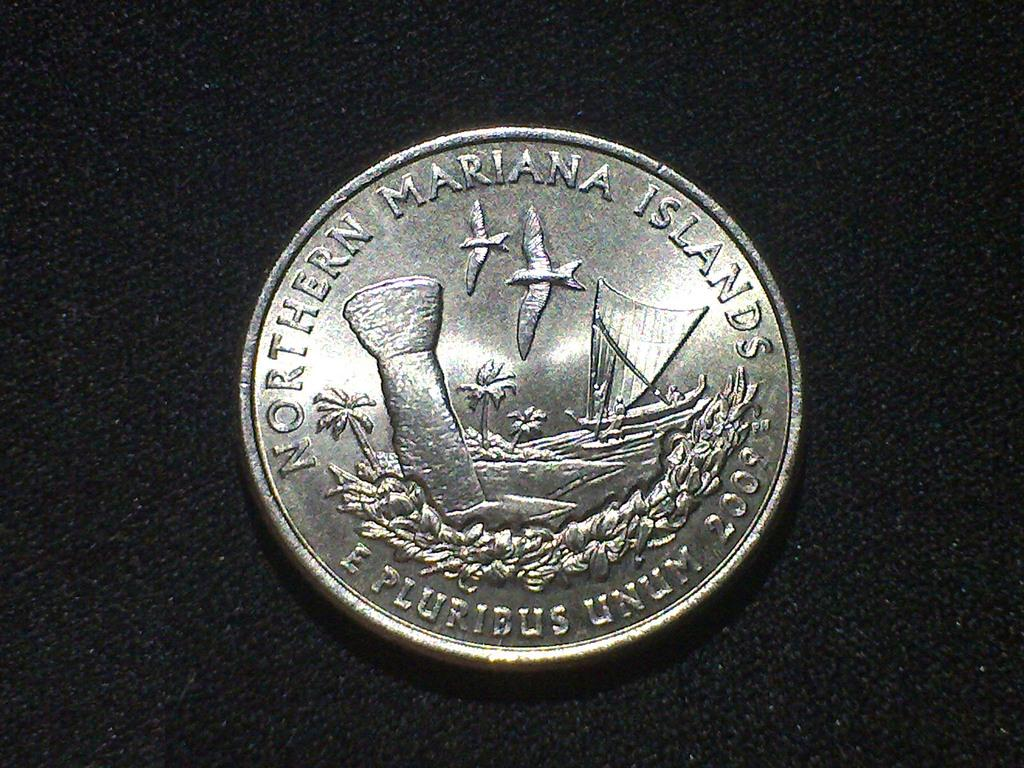<image>
Share a concise interpretation of the image provided. 2009 Northern Mariana Islands is etched onto the back of this coin. 